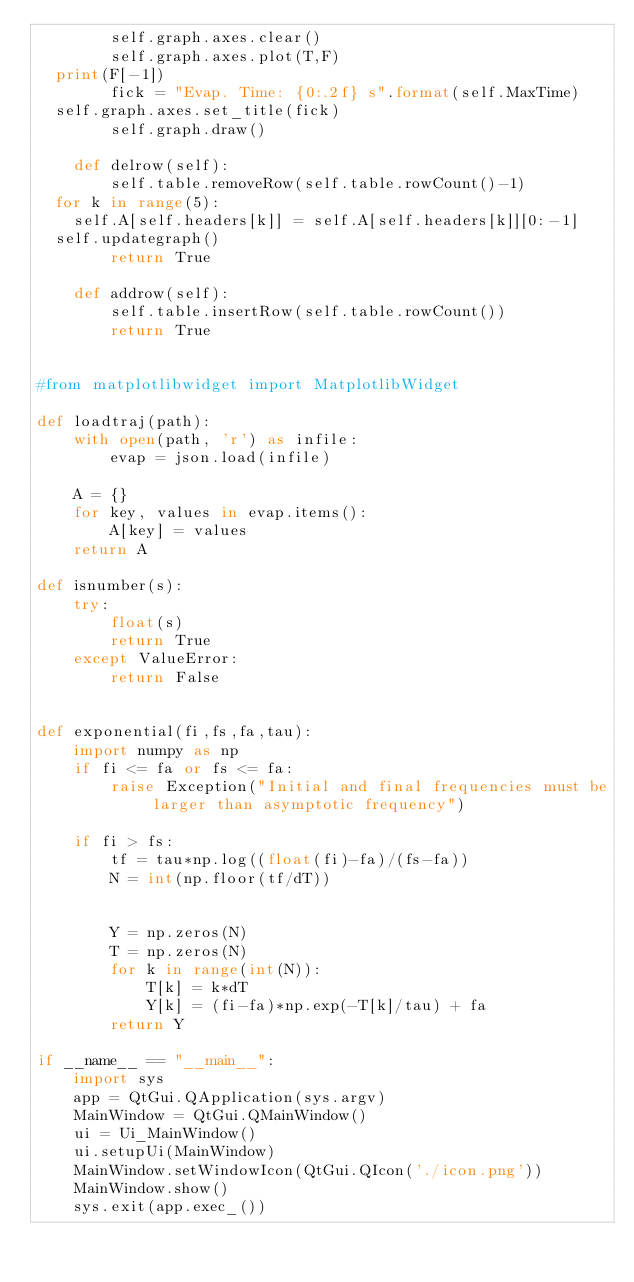<code> <loc_0><loc_0><loc_500><loc_500><_Python_>        self.graph.axes.clear()
        self.graph.axes.plot(T,F)
	print(F[-1])
        fick = "Evap. Time: {0:.2f} s".format(self.MaxTime)
	self.graph.axes.set_title(fick)
        self.graph.draw()

    def delrow(self):
        self.table.removeRow(self.table.rowCount()-1)
	for k in range(5):
		self.A[self.headers[k]] = self.A[self.headers[k]][0:-1]
	self.updategraph()
        return True

    def addrow(self):
        self.table.insertRow(self.table.rowCount())
        return True
     

#from matplotlibwidget import MatplotlibWidget

def loadtraj(path):
    with open(path, 'r') as infile:
        evap = json.load(infile)

    A = {}
    for key, values in evap.items():
        A[key] = values
    return A

def isnumber(s):
    try:
        float(s)
        return True
    except ValueError:
        return False

    
def exponential(fi,fs,fa,tau):
    import numpy as np
    if fi <= fa or fs <= fa:
        raise Exception("Initial and final frequencies must be larger than asymptotic frequency")
    
    if fi > fs:
        tf = tau*np.log((float(fi)-fa)/(fs-fa))
        N = int(np.floor(tf/dT))

        
        Y = np.zeros(N)
        T = np.zeros(N)
        for k in range(int(N)):
            T[k] = k*dT
            Y[k] = (fi-fa)*np.exp(-T[k]/tau) + fa
        return Y

if __name__ == "__main__":
    import sys
    app = QtGui.QApplication(sys.argv)
    MainWindow = QtGui.QMainWindow()
    ui = Ui_MainWindow()
    ui.setupUi(MainWindow)
    MainWindow.setWindowIcon(QtGui.QIcon('./icon.png'))
    MainWindow.show()
    sys.exit(app.exec_())

</code> 